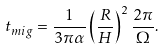Convert formula to latex. <formula><loc_0><loc_0><loc_500><loc_500>t _ { m i g } = \frac { 1 } { 3 \pi \alpha } \left ( \frac { R } { H } \right ) ^ { 2 } \frac { 2 \pi } { \Omega } .</formula> 